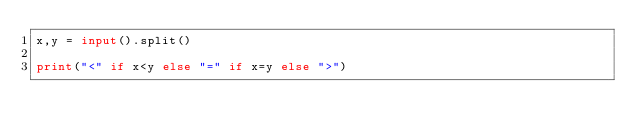Convert code to text. <code><loc_0><loc_0><loc_500><loc_500><_Python_>x,y = input().split()

print("<" if x<y else "=" if x=y else ">")</code> 